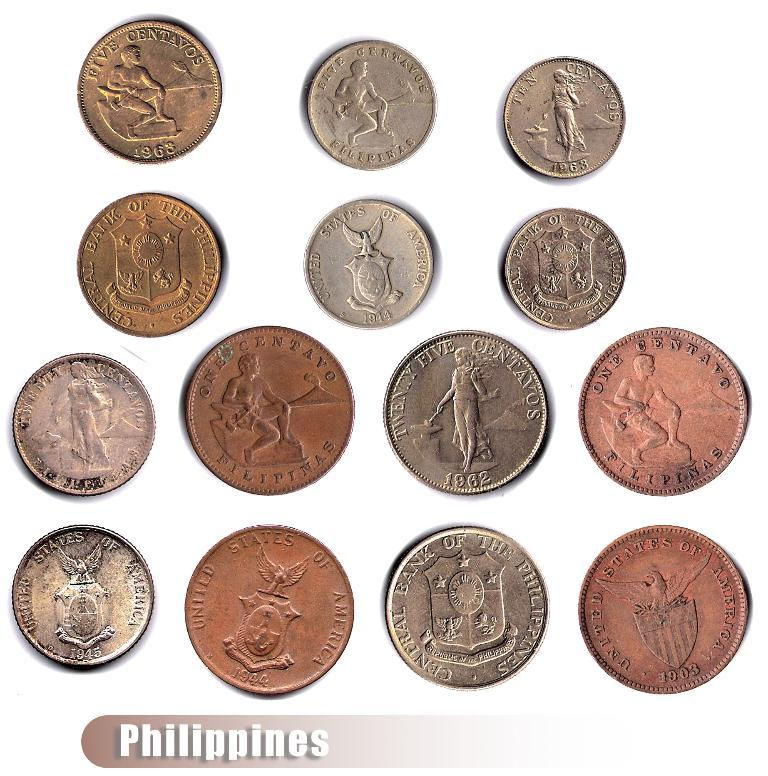<image>
Summarize the visual content of the image. Many coins placed next to one another with the word Philippines near the bottom. 